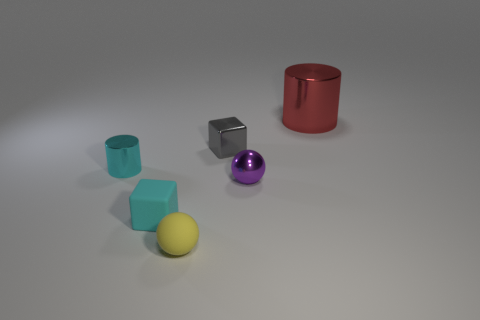Add 2 spheres. How many objects exist? 8 Subtract all cylinders. How many objects are left? 4 Subtract all cyan metal cylinders. Subtract all shiny balls. How many objects are left? 4 Add 4 cylinders. How many cylinders are left? 6 Add 2 small cyan matte blocks. How many small cyan matte blocks exist? 3 Subtract 0 purple cylinders. How many objects are left? 6 